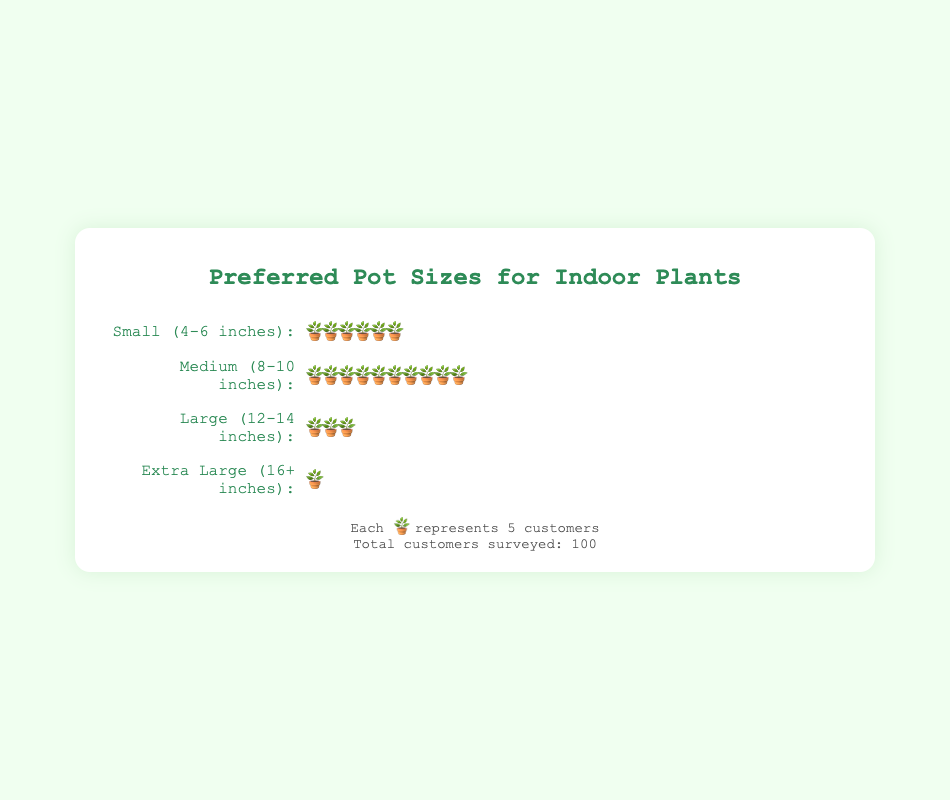What is the most preferred pot size among customers? The most preferred pot size can be determined by finding the one with the highest count of customers. The "Medium (8-10 inches)" category has 10 pots, representing 50 customers, which is the highest count.
Answer: Medium (8-10 inches) How many customers prefer small pots (4-6 inches)? Each pot icon represents 5 customers. The "Small (4-6 inches)" category has 6 pots. Therefore, 6 * 5 = 30 customers.
Answer: 30 What is the total number of customers preferring large and extra-large pots combined? From the figure, "Large (12-14 inches)" has 3 pots (representing 15 customers), and "Extra Large (16+ inches)" has 1 pot (representing 5 customers). Adding these, 15 + 5 = 20 customers prefer either large or extra-large pots.
Answer: 20 Which pot size is the least preferred among customers? The least preferred pot size is the one with the fewest pots. "Extra Large (16+ inches)" has 1 pot, representing 5 customers, which is the smallest number.
Answer: Extra Large (16+ inches) How many total pot icons are displayed in the isotype plot? To find the total number of pot icons, sum all the icons displayed. There are 6 small, 10 medium, 3 large, and 1 extra-large icons: 6 + 10 + 3 + 1 = 20 pot icons.
Answer: 20 If each pot size represents 5 customers, how many pots would be needed to represent 100 small pots? Given that each pot icon represents 5 customers, to represent 100 customers with small pots, divide 100 by 5. 100 / 5 = 20 pots.
Answer: 20 How many more customers prefer medium pots compared to large pots? To compare, find the number of customers for each: Medium (10 pots * 5 = 50 customers), Large (3 pots * 5 = 15 customers). The difference is 50 - 15 = 35 customers.
Answer: 35 Among all the pot sizes, what is the combined total number of customers represented? Sum the customers across all categories: 30 (Small) + 50 (Medium) + 15 (Large) + 5 (Extra Large) = 100 customers. This matches the total provided in the data.
Answer: 100 